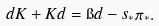<formula> <loc_0><loc_0><loc_500><loc_500>d K + K d = \i d - s _ { * } \pi _ { * } .</formula> 